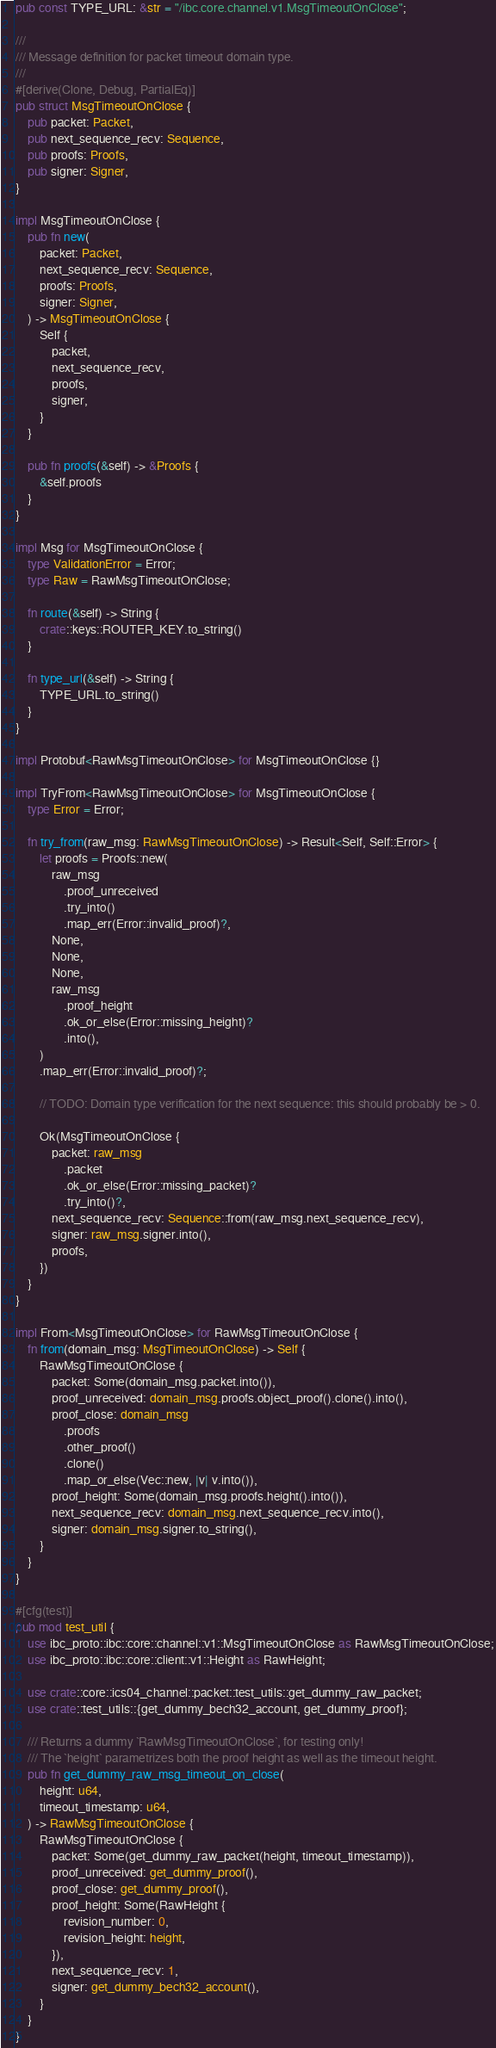Convert code to text. <code><loc_0><loc_0><loc_500><loc_500><_Rust_>pub const TYPE_URL: &str = "/ibc.core.channel.v1.MsgTimeoutOnClose";

///
/// Message definition for packet timeout domain type.
///
#[derive(Clone, Debug, PartialEq)]
pub struct MsgTimeoutOnClose {
    pub packet: Packet,
    pub next_sequence_recv: Sequence,
    pub proofs: Proofs,
    pub signer: Signer,
}

impl MsgTimeoutOnClose {
    pub fn new(
        packet: Packet,
        next_sequence_recv: Sequence,
        proofs: Proofs,
        signer: Signer,
    ) -> MsgTimeoutOnClose {
        Self {
            packet,
            next_sequence_recv,
            proofs,
            signer,
        }
    }

    pub fn proofs(&self) -> &Proofs {
        &self.proofs
    }
}

impl Msg for MsgTimeoutOnClose {
    type ValidationError = Error;
    type Raw = RawMsgTimeoutOnClose;

    fn route(&self) -> String {
        crate::keys::ROUTER_KEY.to_string()
    }

    fn type_url(&self) -> String {
        TYPE_URL.to_string()
    }
}

impl Protobuf<RawMsgTimeoutOnClose> for MsgTimeoutOnClose {}

impl TryFrom<RawMsgTimeoutOnClose> for MsgTimeoutOnClose {
    type Error = Error;

    fn try_from(raw_msg: RawMsgTimeoutOnClose) -> Result<Self, Self::Error> {
        let proofs = Proofs::new(
            raw_msg
                .proof_unreceived
                .try_into()
                .map_err(Error::invalid_proof)?,
            None,
            None,
            None,
            raw_msg
                .proof_height
                .ok_or_else(Error::missing_height)?
                .into(),
        )
        .map_err(Error::invalid_proof)?;

        // TODO: Domain type verification for the next sequence: this should probably be > 0.

        Ok(MsgTimeoutOnClose {
            packet: raw_msg
                .packet
                .ok_or_else(Error::missing_packet)?
                .try_into()?,
            next_sequence_recv: Sequence::from(raw_msg.next_sequence_recv),
            signer: raw_msg.signer.into(),
            proofs,
        })
    }
}

impl From<MsgTimeoutOnClose> for RawMsgTimeoutOnClose {
    fn from(domain_msg: MsgTimeoutOnClose) -> Self {
        RawMsgTimeoutOnClose {
            packet: Some(domain_msg.packet.into()),
            proof_unreceived: domain_msg.proofs.object_proof().clone().into(),
            proof_close: domain_msg
                .proofs
                .other_proof()
                .clone()
                .map_or_else(Vec::new, |v| v.into()),
            proof_height: Some(domain_msg.proofs.height().into()),
            next_sequence_recv: domain_msg.next_sequence_recv.into(),
            signer: domain_msg.signer.to_string(),
        }
    }
}

#[cfg(test)]
pub mod test_util {
    use ibc_proto::ibc::core::channel::v1::MsgTimeoutOnClose as RawMsgTimeoutOnClose;
    use ibc_proto::ibc::core::client::v1::Height as RawHeight;

    use crate::core::ics04_channel::packet::test_utils::get_dummy_raw_packet;
    use crate::test_utils::{get_dummy_bech32_account, get_dummy_proof};

    /// Returns a dummy `RawMsgTimeoutOnClose`, for testing only!
    /// The `height` parametrizes both the proof height as well as the timeout height.
    pub fn get_dummy_raw_msg_timeout_on_close(
        height: u64,
        timeout_timestamp: u64,
    ) -> RawMsgTimeoutOnClose {
        RawMsgTimeoutOnClose {
            packet: Some(get_dummy_raw_packet(height, timeout_timestamp)),
            proof_unreceived: get_dummy_proof(),
            proof_close: get_dummy_proof(),
            proof_height: Some(RawHeight {
                revision_number: 0,
                revision_height: height,
            }),
            next_sequence_recv: 1,
            signer: get_dummy_bech32_account(),
        }
    }
}
</code> 